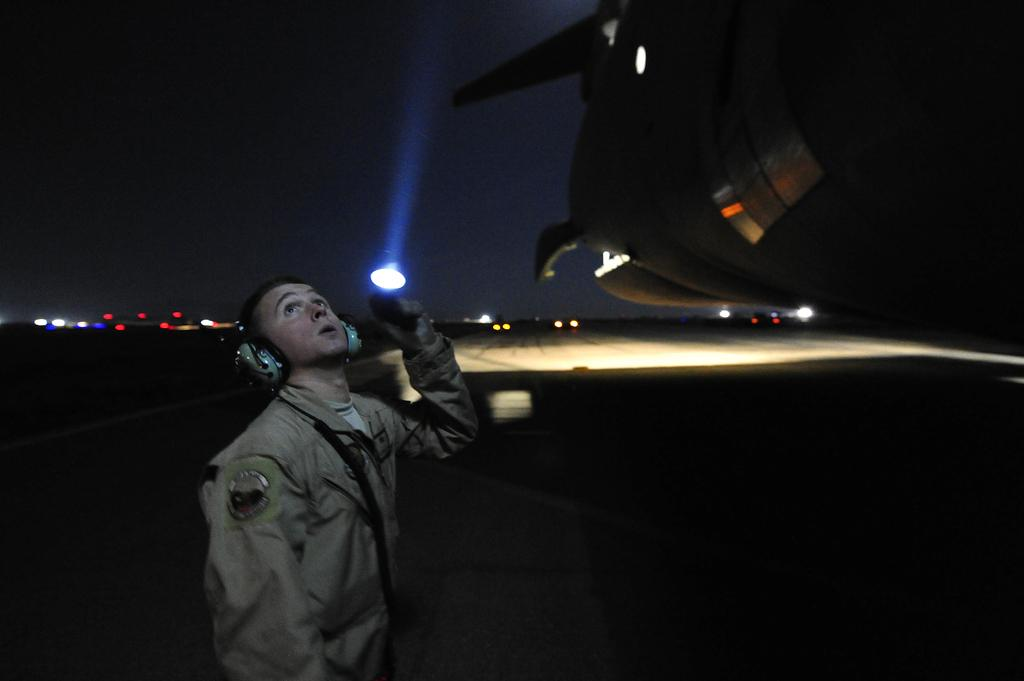Who is present in the image? There is a man in the image. What can be seen in the image besides the man? There are lights and objects visible in the image. What is visible in the background of the image? The sky is visible in the background of the image. What type of letter is the giant holding in the image? There are no giants or letters present in the image. What appliance is being used by the man in the image? The provided facts do not mention any appliances being used by the man in the image. 